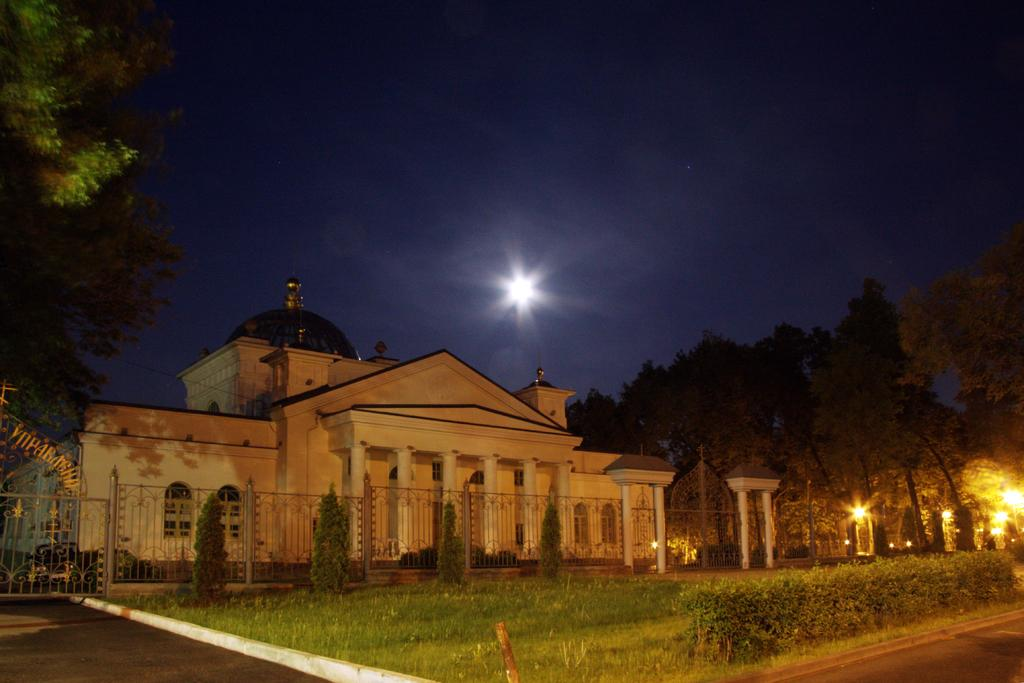What type of vegetation can be seen in the image? There are shrubs and grass in the image. What architectural features are present in the image? There is a gate, a fence, and a building in the image. What is the source of illumination in the image? There is a light pole in the image. What celestial body is visible in the image? The moon is visible in the image. What is the color of the sky in the background of the image? The sky in the background of the image is dark. What type of wren can be seen perched on the gate in the image? There is no wren present in the image; only shrubs, grass, a gate, a fence, a building, trees, a light pole, the moon, and a dark sky are visible. What type of trade is being conducted in the image? There is no indication of any trade or transaction taking place in the image. What form does the moon take in the image? The moon appears as a celestial body in the image, but its specific form or shape cannot be determined from the image alone. 